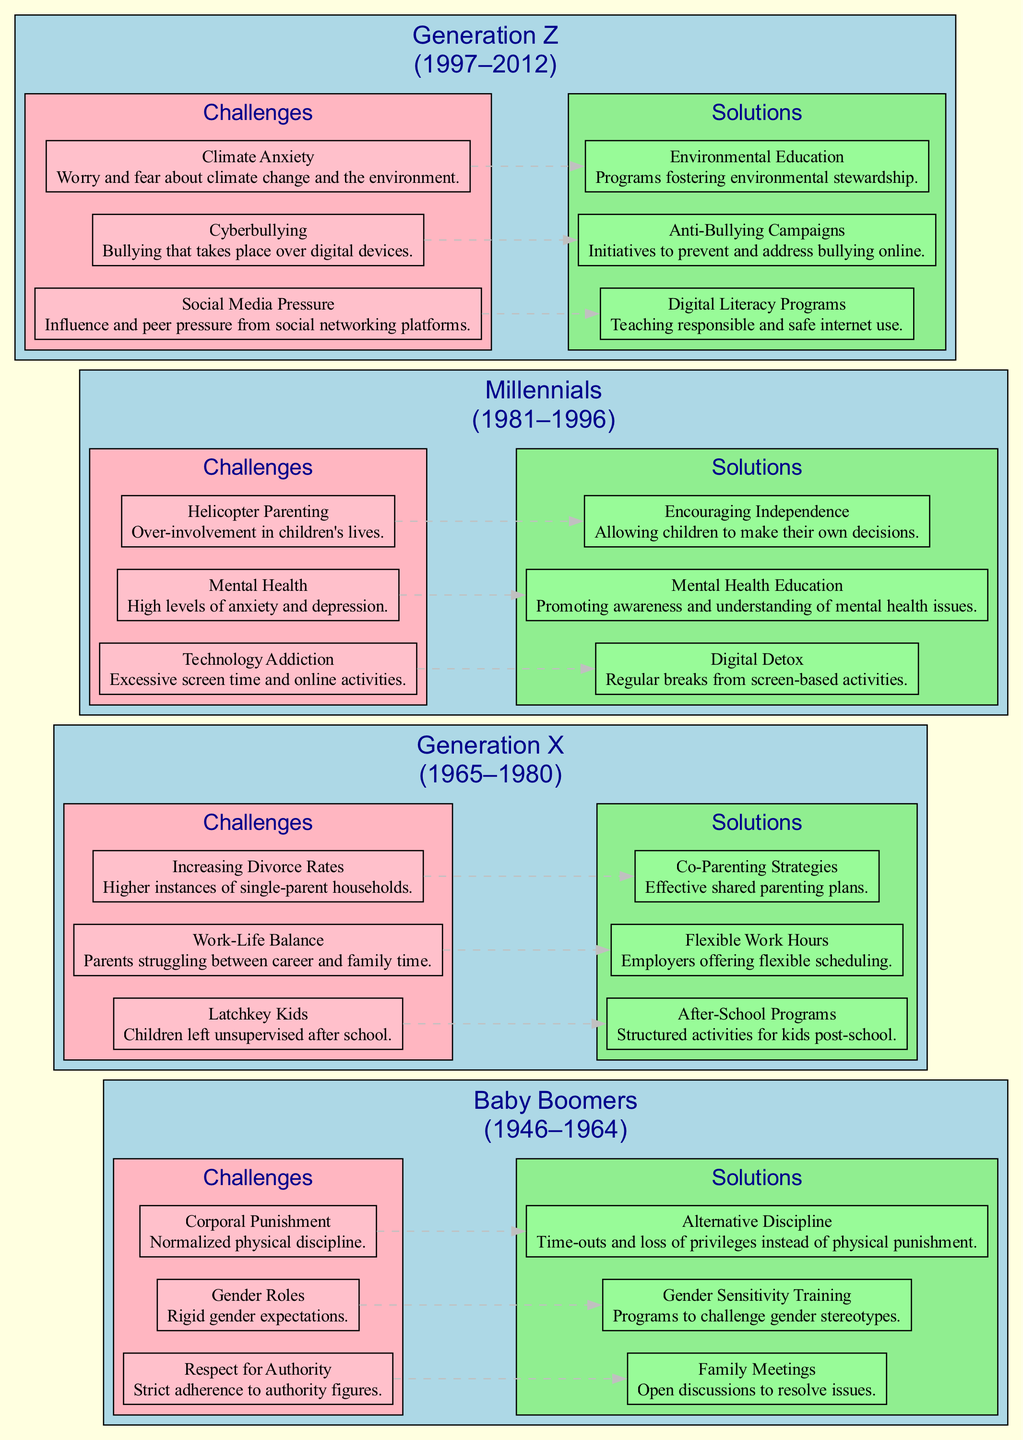What are the years associated with Generation X? From the diagram, Generation X is labeled with the years 1965–1980 underneath its name.
Answer: 1965–1980 How many challenges are listed for Millennials? By examining the "Challenges" section under Millennials in the diagram, it shows there are three distinct challenges mentioned.
Answer: 3 What is one solution for Baby Boomers? The diagram shows multiple solutions, one of which is "Family Meetings" located under the "Solutions" section for Baby Boomers.
Answer: Family Meetings Which generation faces "Social Media Pressure"? The diagram indicates that "Social Media Pressure" is a challenge specifically associated with Generation Z, as evident under its "Challenges" section.
Answer: Generation Z What is the relationship between "Corporal Punishment" and "Alternative Discipline"? In the diagram, there is a dashed gray line connecting "Corporal Punishment" under Baby Boomers' challenges to "Alternative Discipline" under their solutions, indicating a proposed solution for that challenge.
Answer: Alternative Discipline What is the total number of edges (relationships) in the Generation X section? By counting the dashed edges between each challenge and its corresponding solution in the Generation X section, there are three connections noted: one for each challenge.
Answer: 3 What challenge is associated with high levels of anxiety for Millennials? The diagram specifies "Mental Health" as a challenge related to anxiety and depression under the Millennials' challenges.
Answer: Mental Health What does "Environmental Education" aim to address in Generation Z? Located under the "Solutions" section for Generation Z, "Environmental Education" addresses the challenge of "Climate Anxiety" by fostering environmental stewardship.
Answer: Climate Anxiety 